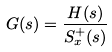Convert formula to latex. <formula><loc_0><loc_0><loc_500><loc_500>G ( s ) = \frac { H ( s ) } { S _ { x } ^ { + } ( s ) }</formula> 